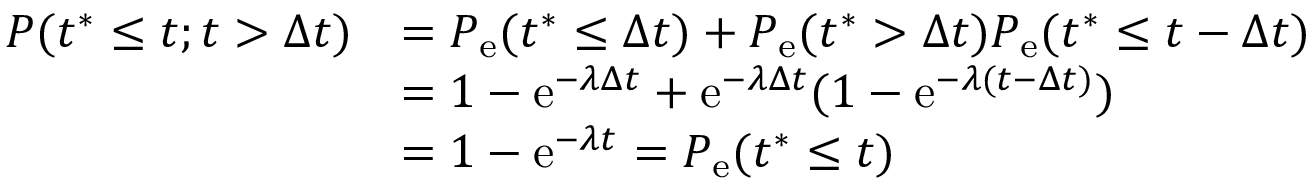Convert formula to latex. <formula><loc_0><loc_0><loc_500><loc_500>\begin{array} { r l } { P ( t ^ { \ast } \leq t ; t > \Delta t ) } & { = P _ { e } ( t ^ { \ast } \leq \Delta t ) + P _ { e } ( t ^ { \ast } > \Delta t ) P _ { e } ( t ^ { \ast } \leq t - \Delta t ) } \\ & { = 1 - e ^ { - \lambda \Delta t } + e ^ { - \lambda \Delta t } ( 1 - e ^ { - \lambda ( t - \Delta t ) } ) } \\ & { = 1 - e ^ { - \lambda t } = P _ { e } ( t ^ { \ast } \leq t ) } \end{array}</formula> 